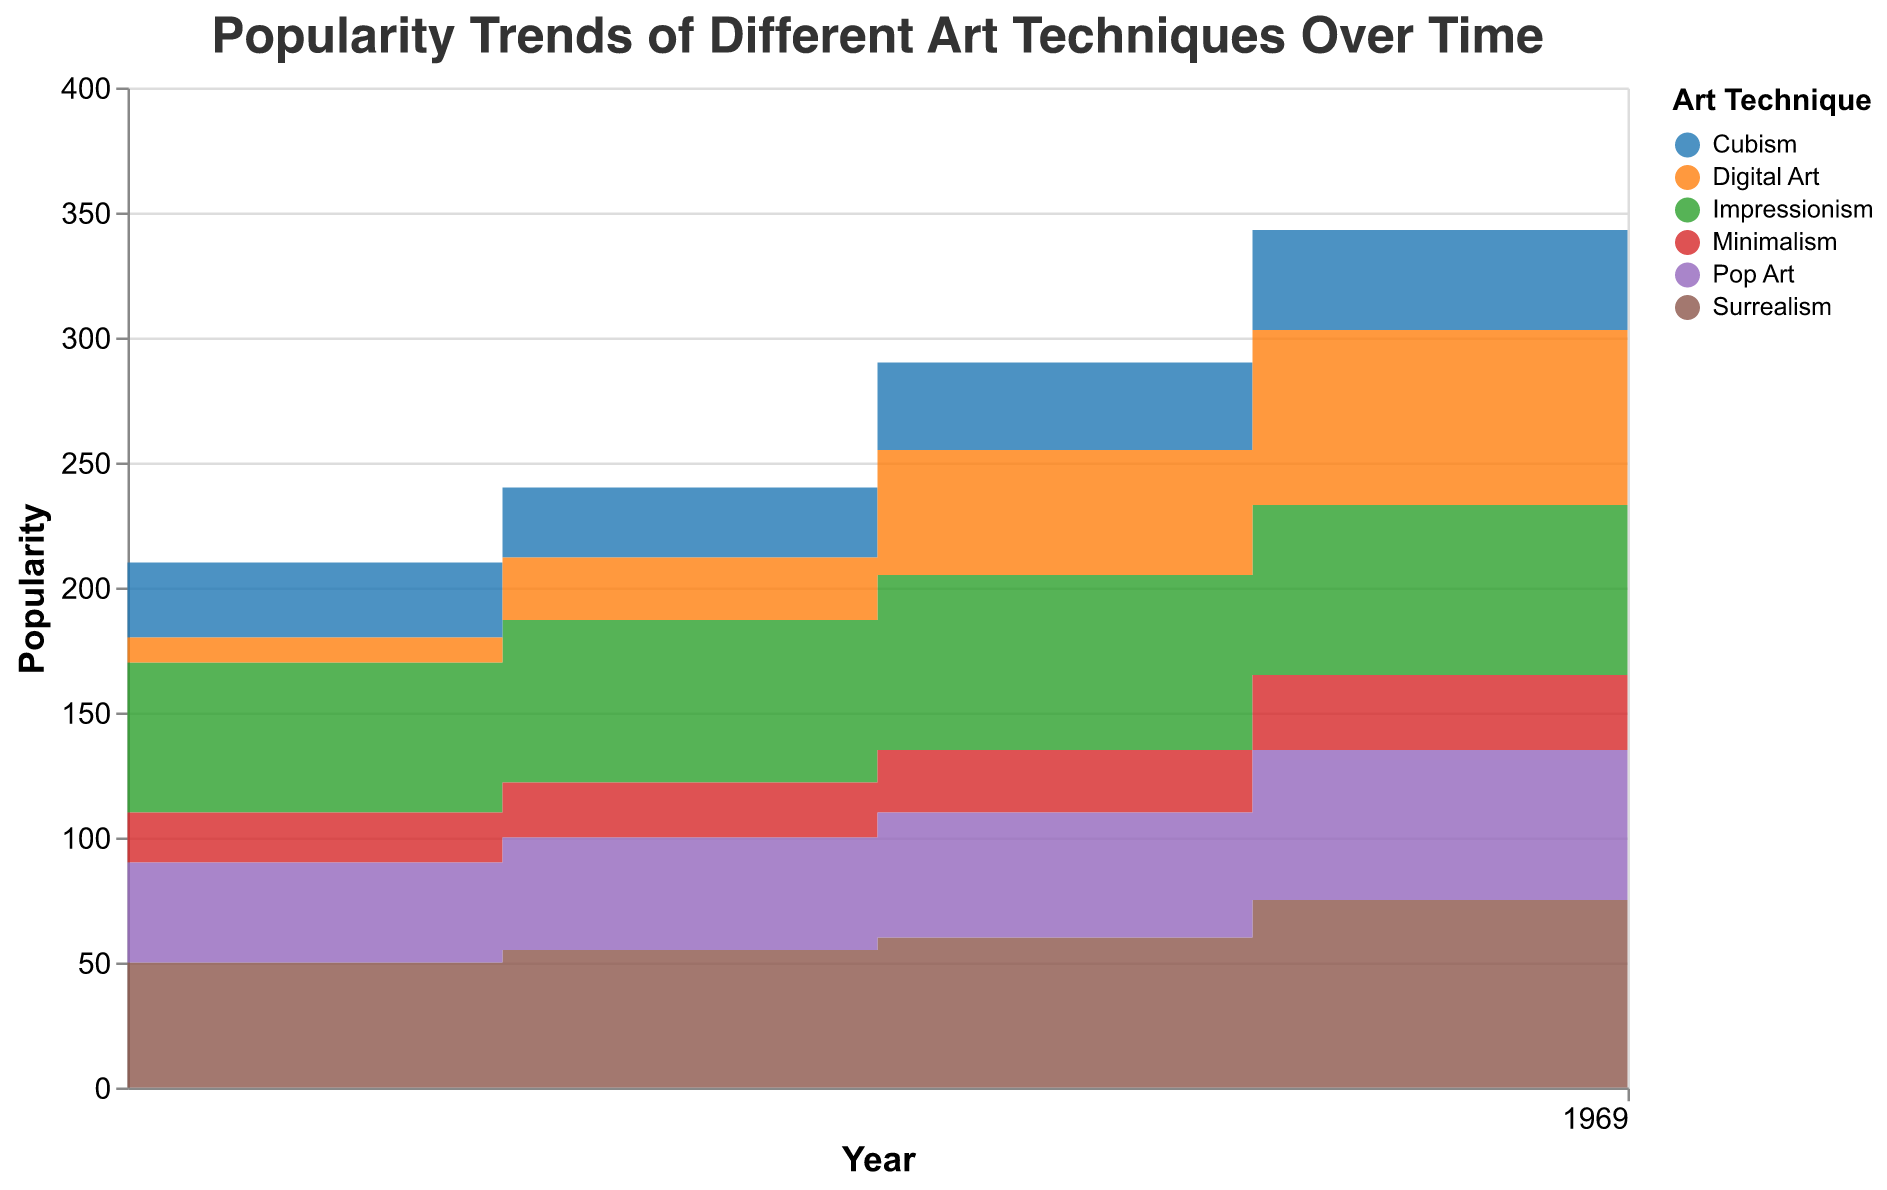What's the title of the figure? The title of the figure is usually at the top and labeled with a font style or size that makes it stand out. In this figure, the title is "Popularity Trends of Different Art Techniques Over Time"
Answer: Popularity Trends of Different Art Techniques Over Time How many art techniques are displayed in the figure? The figure uses color to distinguish between different art techniques, and the legend lists them. By counting the categories listed in the legend, there are six art techniques: Impressionism, Surrealism, Cubism, Digital Art, Minimalism, and Pop Art
Answer: 6 Which art technique had the highest popularity in the year 2020? By observing the figure and focusing on the data points plotted for the year 2020, we can see that Digital Art reaches the highest value compared to other techniques.
Answer: Digital Art How did the popularity of Surrealism change between the years 2000 and 2020? Looking at the data points for Surrealism in both years 2000 and 2020, we see it increased from 50 to 80. Calculating the difference, 80 - 50 = 30.
Answer: Increased by 30 Which two art techniques had the closest popularity values in 2015? By comparing the popularity values of each art technique for the year 2015, we see that Impressionism (68) and Pop Art (60) were closest, with a difference of 68 - 60 = 8.
Answer: Impressionism and Pop Art Among the art techniques, which one had the most consistent increase in popularity over time? Observing the trends for each technique, Digital Art had a steady increase from 10 in 2000 to 90 in 2020 in a linear pattern.
Answer: Digital Art Which art technique experienced the highest single-year increase in popularity? By checking the sharpest increases between successive years for each technique, Surrealism jumps significantly between 2010 (60) and 2015 (75), a difference of 15.
Answer: Surrealism What was the total popularity across all art techniques in the year 2005? Adding up the popularity values for each art technique in 2005: Impressionism (65) + Surrealism (55) + Cubism (28) + Digital Art (25) + Minimalism (22) + Pop Art (45) = 240.
Answer: 240 